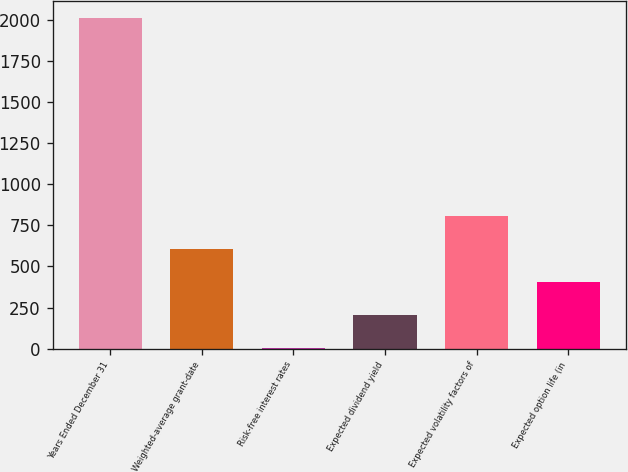Convert chart to OTSL. <chart><loc_0><loc_0><loc_500><loc_500><bar_chart><fcel>Years Ended December 31<fcel>Weighted-average grant-date<fcel>Risk-free interest rates<fcel>Expected dividend yield<fcel>Expected volatility factors of<fcel>Expected option life (in<nl><fcel>2012<fcel>605.1<fcel>2.16<fcel>203.14<fcel>806.08<fcel>404.12<nl></chart> 